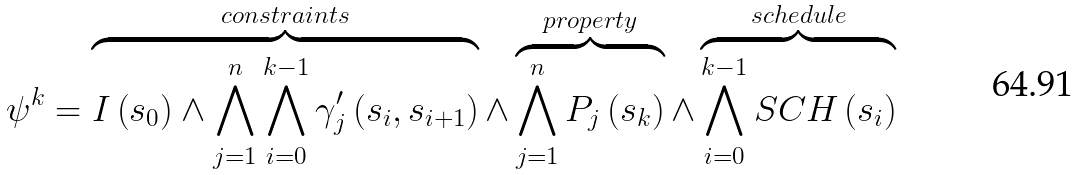Convert formula to latex. <formula><loc_0><loc_0><loc_500><loc_500>\psi ^ { k } = \overbrace { I \left ( s _ { 0 } \right ) \wedge \bigwedge ^ { n } _ { j = 1 } \bigwedge ^ { k - 1 } _ { i = 0 } \gamma ^ { \prime } _ { j } \left ( s _ { i } , s _ { i + 1 } \right ) } ^ { c o n s t r a i n t s } \wedge \overbrace { \bigwedge ^ { n } _ { j = 1 } P _ { j } \left ( s _ { k } \right ) } ^ { p r o p e r t y } \wedge \overbrace { \bigwedge ^ { k - 1 } _ { i = 0 } S C H \left ( s _ { i } \right ) } ^ { s c h e d u l e }</formula> 